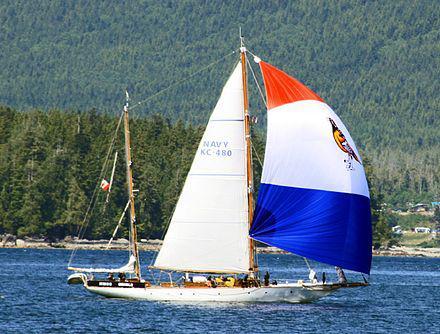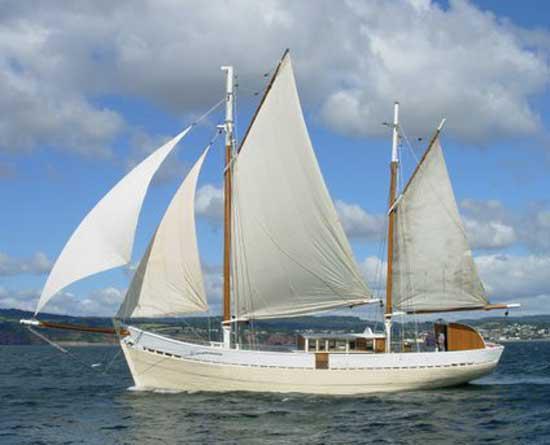The first image is the image on the left, the second image is the image on the right. Examine the images to the left and right. Is the description "At least one of the ship has at least one sail that is not up." accurate? Answer yes or no. Yes. The first image is the image on the left, the second image is the image on the right. Assess this claim about the two images: "There are no visible clouds in one of the images within the pair.". Correct or not? Answer yes or no. Yes. 